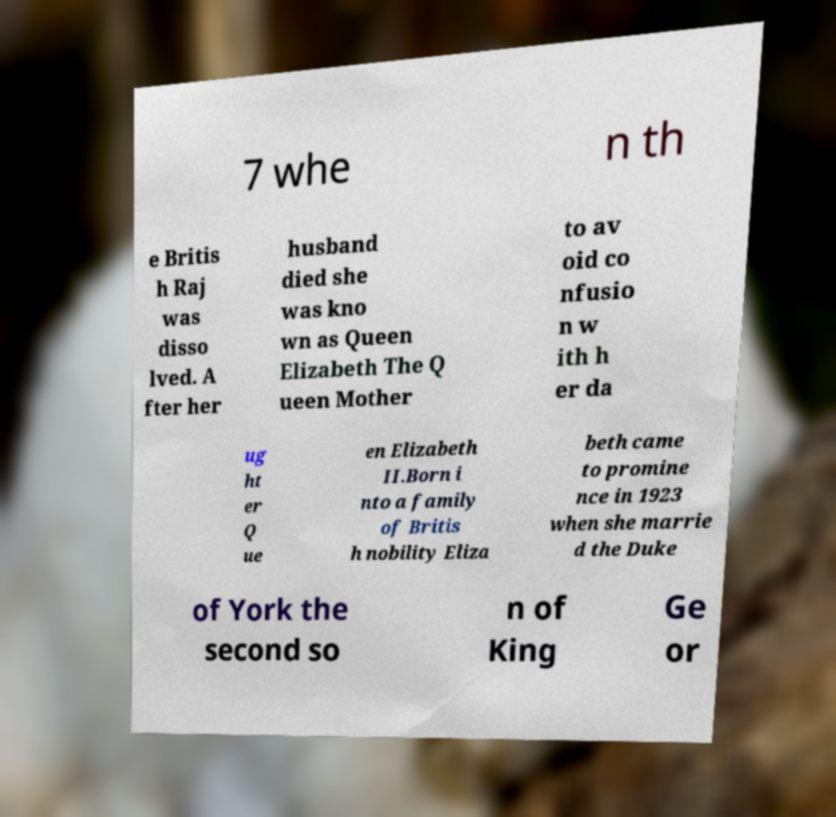Please read and relay the text visible in this image. What does it say? 7 whe n th e Britis h Raj was disso lved. A fter her husband died she was kno wn as Queen Elizabeth The Q ueen Mother to av oid co nfusio n w ith h er da ug ht er Q ue en Elizabeth II.Born i nto a family of Britis h nobility Eliza beth came to promine nce in 1923 when she marrie d the Duke of York the second so n of King Ge or 